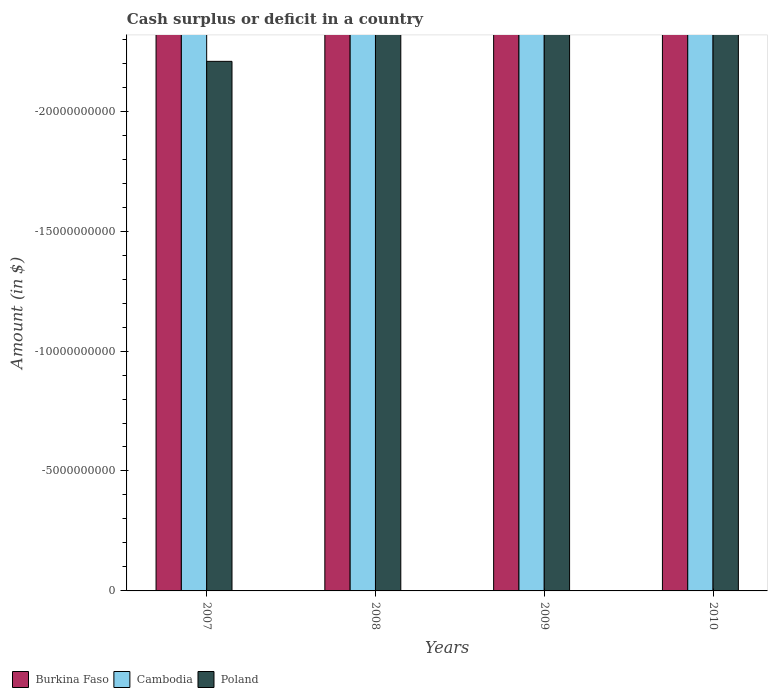Are the number of bars per tick equal to the number of legend labels?
Your response must be concise. No. How many bars are there on the 1st tick from the right?
Make the answer very short. 0. In how many cases, is the number of bars for a given year not equal to the number of legend labels?
Offer a terse response. 4. What is the total amount of cash surplus or deficit in Cambodia in the graph?
Offer a terse response. 0. What is the difference between the amount of cash surplus or deficit in Poland in 2008 and the amount of cash surplus or deficit in Cambodia in 2010?
Make the answer very short. 0. What is the average amount of cash surplus or deficit in Cambodia per year?
Provide a succinct answer. 0. Is it the case that in every year, the sum of the amount of cash surplus or deficit in Cambodia and amount of cash surplus or deficit in Burkina Faso is greater than the amount of cash surplus or deficit in Poland?
Ensure brevity in your answer.  No. How many bars are there?
Offer a very short reply. 0. How many years are there in the graph?
Your response must be concise. 4. What is the difference between two consecutive major ticks on the Y-axis?
Make the answer very short. 5.00e+09. Does the graph contain grids?
Provide a short and direct response. No. Where does the legend appear in the graph?
Offer a very short reply. Bottom left. How are the legend labels stacked?
Ensure brevity in your answer.  Horizontal. What is the title of the graph?
Provide a short and direct response. Cash surplus or deficit in a country. Does "Egypt, Arab Rep." appear as one of the legend labels in the graph?
Offer a terse response. No. What is the label or title of the Y-axis?
Your answer should be compact. Amount (in $). What is the Amount (in $) in Burkina Faso in 2007?
Offer a terse response. 0. What is the Amount (in $) of Cambodia in 2007?
Your answer should be compact. 0. What is the Amount (in $) of Poland in 2007?
Your answer should be very brief. 0. What is the Amount (in $) of Burkina Faso in 2008?
Make the answer very short. 0. What is the Amount (in $) in Poland in 2008?
Make the answer very short. 0. What is the Amount (in $) of Burkina Faso in 2009?
Offer a very short reply. 0. What is the Amount (in $) of Cambodia in 2009?
Your response must be concise. 0. What is the Amount (in $) of Cambodia in 2010?
Provide a succinct answer. 0. What is the Amount (in $) of Poland in 2010?
Your answer should be very brief. 0. What is the total Amount (in $) in Cambodia in the graph?
Offer a terse response. 0. What is the total Amount (in $) of Poland in the graph?
Your answer should be very brief. 0. What is the average Amount (in $) in Burkina Faso per year?
Keep it short and to the point. 0. What is the average Amount (in $) in Poland per year?
Your response must be concise. 0. 